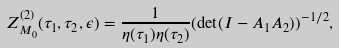<formula> <loc_0><loc_0><loc_500><loc_500>Z _ { M _ { 0 } } ^ { ( 2 ) } ( \tau _ { 1 } , \tau _ { 2 } , \epsilon ) = \frac { 1 } { \eta ( \tau _ { 1 } ) \eta ( \tau _ { 2 } ) } ( \det ( I - A _ { 1 } A _ { 2 } ) ) ^ { - 1 / 2 } ,</formula> 